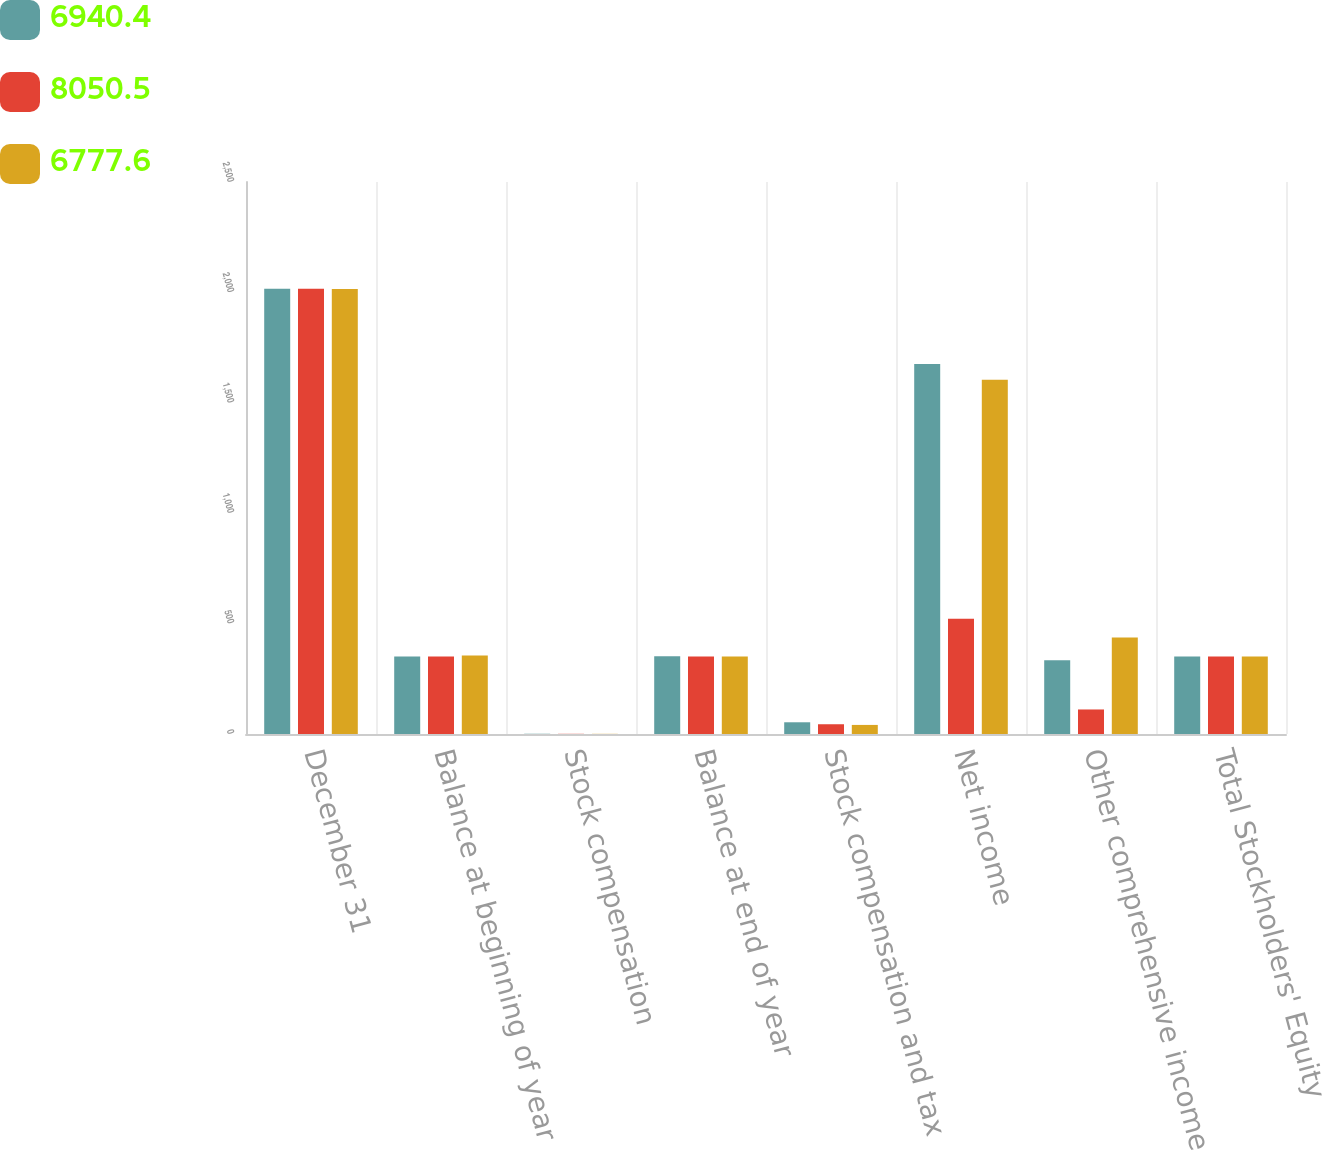<chart> <loc_0><loc_0><loc_500><loc_500><stacked_bar_chart><ecel><fcel>December 31<fcel>Balance at beginning of year<fcel>Stock compensation<fcel>Balance at end of year<fcel>Stock compensation and tax<fcel>Net income<fcel>Other comprehensive income<fcel>Total Stockholders' Equity<nl><fcel>6940.4<fcel>2017<fcel>350.7<fcel>1.1<fcel>351.8<fcel>53.1<fcel>1675.2<fcel>334.5<fcel>351.3<nl><fcel>8050.5<fcel>2016<fcel>351.3<fcel>0.8<fcel>350.7<fcel>44.2<fcel>521.7<fcel>111.1<fcel>351.3<nl><fcel>6777.6<fcel>2015<fcel>355.2<fcel>0.7<fcel>351.3<fcel>41.1<fcel>1604<fcel>437.2<fcel>351.3<nl></chart> 